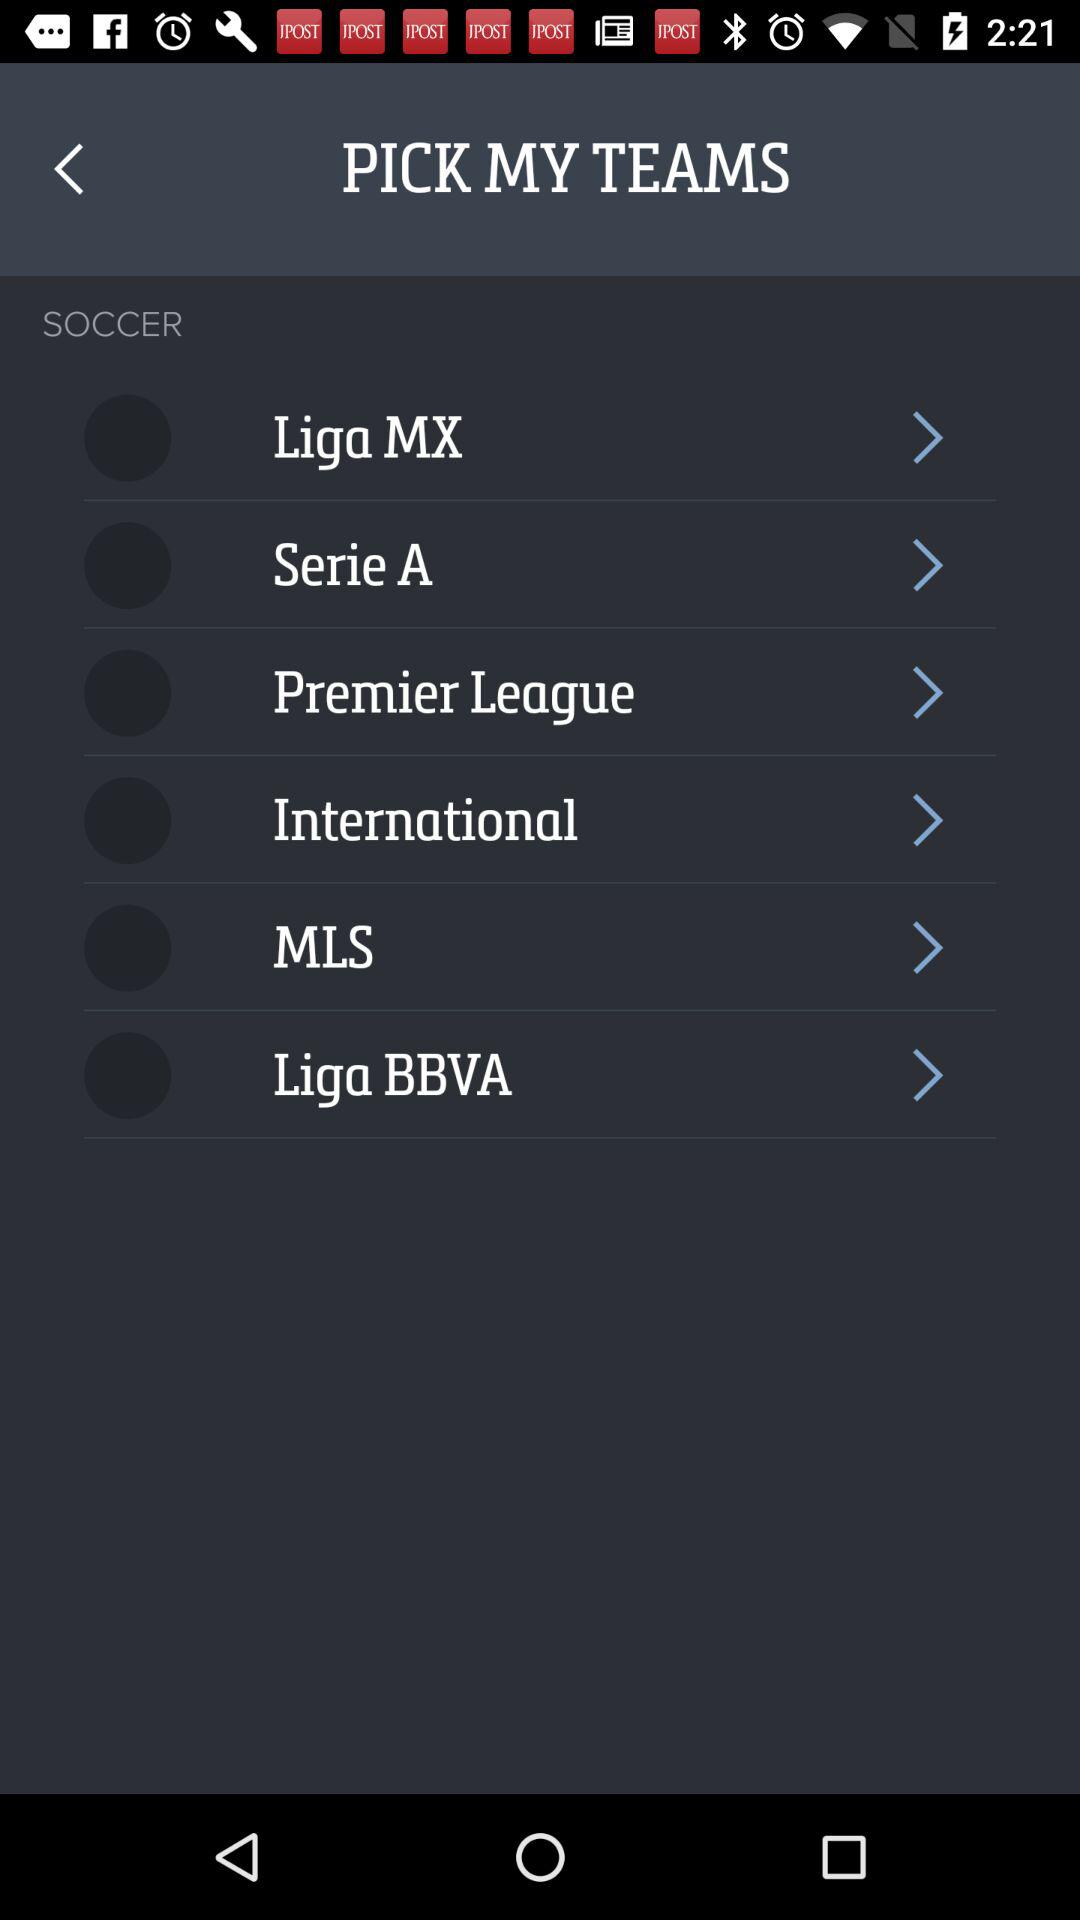How many sports leagues are available to choose from?
Answer the question using a single word or phrase. 6 